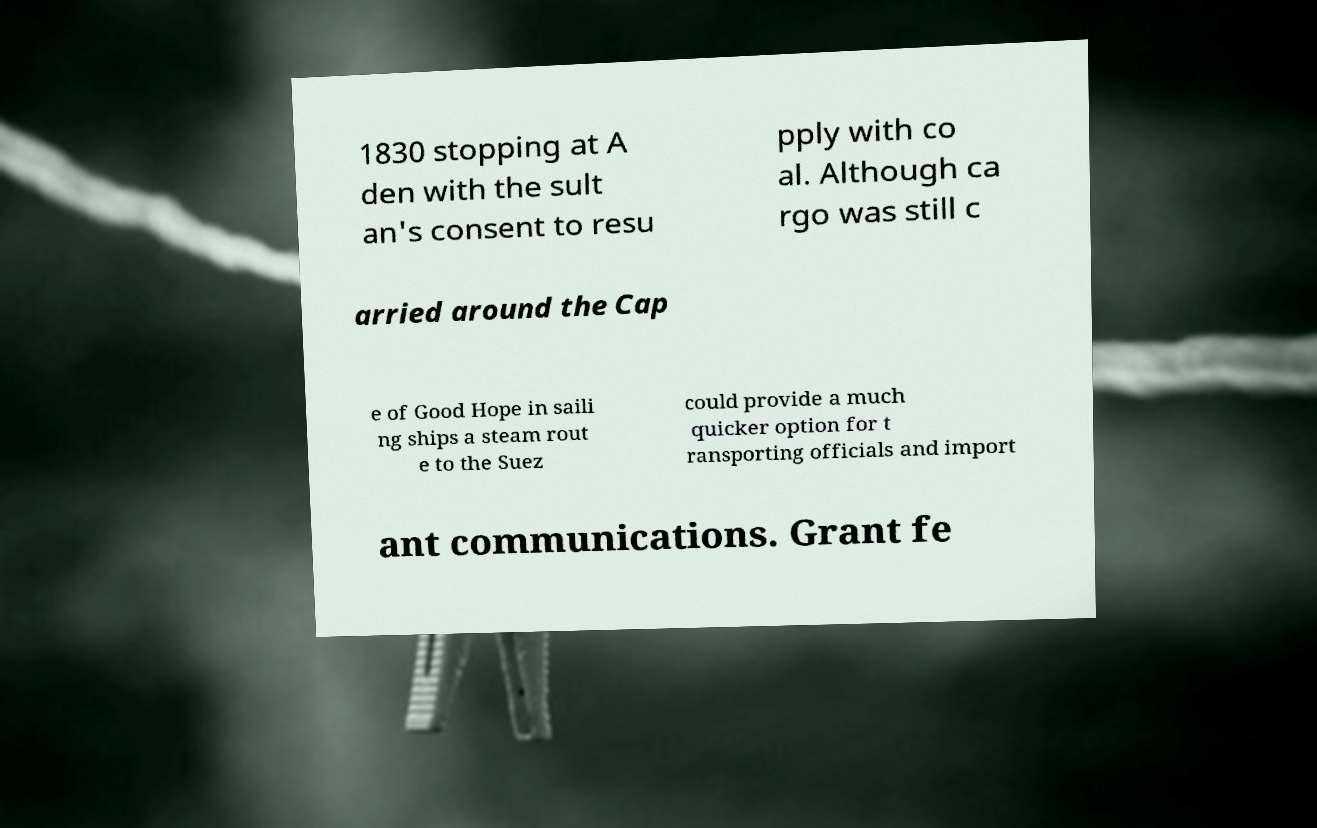I need the written content from this picture converted into text. Can you do that? 1830 stopping at A den with the sult an's consent to resu pply with co al. Although ca rgo was still c arried around the Cap e of Good Hope in saili ng ships a steam rout e to the Suez could provide a much quicker option for t ransporting officials and import ant communications. Grant fe 